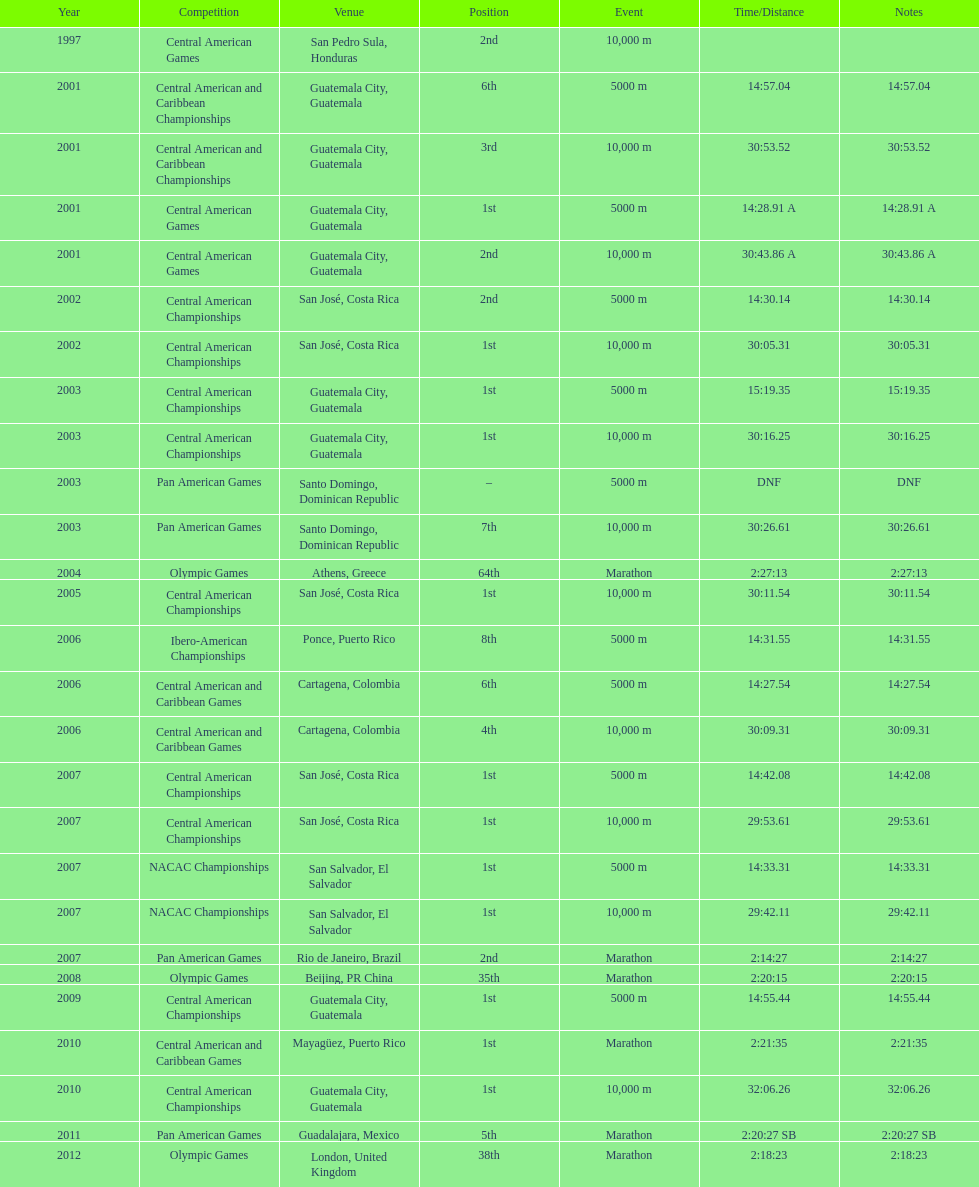What competition did this competitor compete at after participating in the central american games in 2001? Central American Championships. 